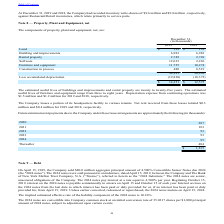According to Par Technology's financial document, What is the estimated useful lives of furniture and equipment? range from three to eight years.. The document states: "estimated useful lives of furniture and equipment range from three to eight years. Depreciation expense from continuing operations was $1.5 million an..." Also, What was the Depreciation expense from continuing operations for 2019 and 2018 respectively? The document shows two values: $1.5 million and $1.2 million. From the document: "se from continuing operations was $1.5 million and $1.2 million for 2019 and 2018, respectively. epreciation expense from continuing operations was $1..." Also, How much was the Net rent received from leases for 2019 and 2018 respectively? The document shows two values: $0.3 million and $0.4 million. From the document: "eceived from these leases totaled $0.3 million and $0.4 million for 2019 and 2018, respectively. nants. Net rent received from these leases totaled $0..." Also, can you calculate: What is the change in Furniture and equipment between December 31, 2018 and 2019? Based on the calculation: 11,755-10,274, the result is 1481 (in thousands). This is based on the information: "Furniture and equipment 11,755 10,274 Furniture and equipment 11,755 10,274..." The key data points involved are: 10,274, 11,755. Also, can you calculate: What is the change in accumulated depreciation between December 31, 2018 and 2019? Based on the calculation: 19,830-18,375, the result is 1455 (in thousands). This is based on the information: "Less accumulated depreciation (19,830) (18,375) Less accumulated depreciation (19,830) (18,375)..." The key data points involved are: 18,375, 19,830. Also, can you calculate: What is the average Furniture and equipment for December 31, 2018 and 2019? To answer this question, I need to perform calculations using the financial data. The calculation is: (11,755+10,274) / 2, which equals 11014.5 (in thousands). This is based on the information: "Furniture and equipment 11,755 10,274 Furniture and equipment 11,755 10,274..." The key data points involved are: 10,274, 11,755. 